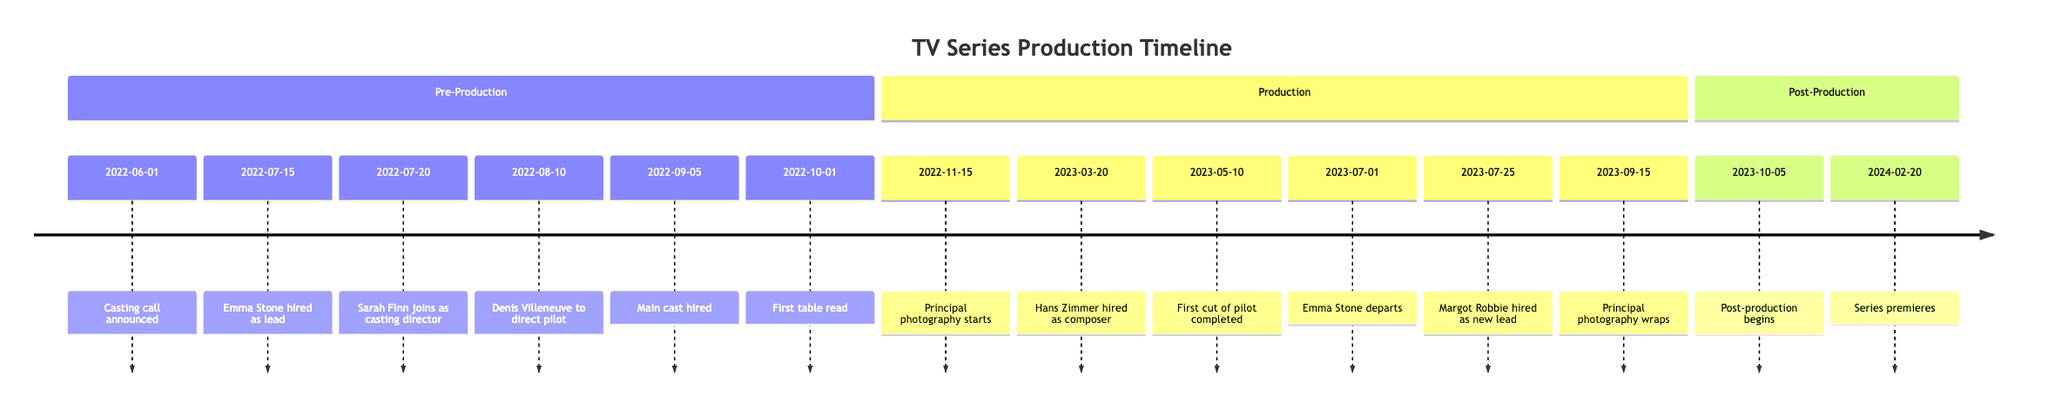What date was the casting call announced? The timeline lists "2022-06-01" as the date when the casting call was announced.
Answer: 2022-06-01 Who was hired as the lead actor? According to the timeline, "Emma Stone" was hired as the lead actor on "2022-07-15".
Answer: Emma Stone When did principal photography start? The timeline states that principal photography started on "2022-11-15".
Answer: 2022-11-15 What event occurred on March 20, 2023? The entry for "2023-03-20" indicates that "Hans Zimmer" was hired as the composer.
Answer: Hans Zimmer How many main cast members were hired on September 5, 2022? The timeline shows that three main cast members were hired on "2022-09-05", specifically listing their characters in the details.
Answer: 3 What significant change happened on July 1, 2023? The timeline notes that "Emma Stone" departed the project on this date due to scheduling conflicts.
Answer: Emma Stone departs What event marks the end of the principal photography phase? The timeline indicates that "2023-09-15" was the date when "Principal photography wrapped".
Answer: Principal photography wraps Who took over the lead role after Emma Stone's departure? The event on "2023-07-25" states that "Margot Robbie" was hired as the new lead actor.
Answer: Margot Robbie When did the first episode air? The timeline clearly states that the series premiered on "2024-02-20".
Answer: 2024-02-20 